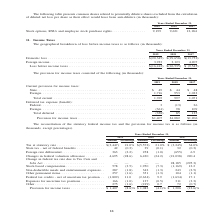According to A10 Networks's financial document, What is the company's domestic loss in 2019? According to the financial document, $(20,345) (in thousands). The relevant text states: "Domestic loss . $(20,345) $(29,658) $(13,752) Foreign income . 3,933 3,123 4,207..." Also, What is the company's domestic loss in 2018? According to the financial document, $(29,658) (in thousands). The relevant text states: "Domestic loss . $(20,345) $(29,658) $(13,752) Foreign income . 3,933 3,123 4,207..." Also, What is the company's domestic loss in 2017? According to the financial document, $(13,752) (in thousands). The relevant text states: "Domestic loss . $(20,345) $(29,658) $(13,752) Foreign income . 3,933 3,123 4,207..." Also, can you calculate: What is the company's total loss before income taxes between 2017 to 2019? Based on the calculation: $(16,412) + $(26,535) + $(9,545), the result is -52492 (in thousands). This is based on the information: "Loss before income taxes . $(16,412) $(26,535) $ (9,545) Loss before income taxes . $(16,412) $(26,535) $ (9,545) Loss before income taxes . $(16,412) $(26,535) $ (9,545)..." The key data points involved are: 16,412, 26,535, 9,545. Also, can you calculate: What is the company's change in foreign income between 2018 and 2019? To answer this question, I need to perform calculations using the financial data. The calculation is: (3,933 - 3,123)/3,123 , which equals 25.94 (percentage). This is based on the information: ". $(20,345) $(29,658) $(13,752) Foreign income . 3,933 3,123 4,207 0,345) $(29,658) $(13,752) Foreign income . 3,933 3,123 4,207..." The key data points involved are: 3,123, 3,933. Also, can you calculate: What is the company's total domestic loss between 2017 to 2019? Based on the calculation: $(20,345) + $(29,658) + $(13,752) , the result is -63755 (in thousands). This is based on the information: "Domestic loss . $(20,345) $(29,658) $(13,752) Foreign income . 3,933 3,123 4,207 Domestic loss . $(20,345) $(29,658) $(13,752) Foreign income . 3,933 3,123 4,207 Domestic loss . $(20,345) $(29,658) $(..." The key data points involved are: 13,752, 20,345, 29,658. 